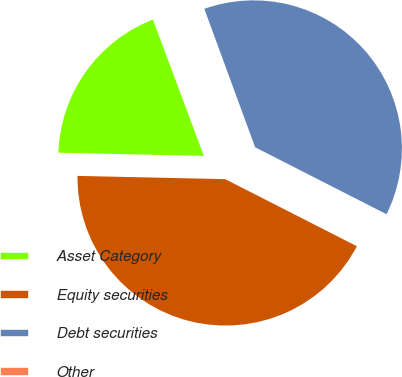<chart> <loc_0><loc_0><loc_500><loc_500><pie_chart><fcel>Asset Category<fcel>Equity securities<fcel>Debt securities<fcel>Other<nl><fcel>18.96%<fcel>42.85%<fcel>38.1%<fcel>0.09%<nl></chart> 